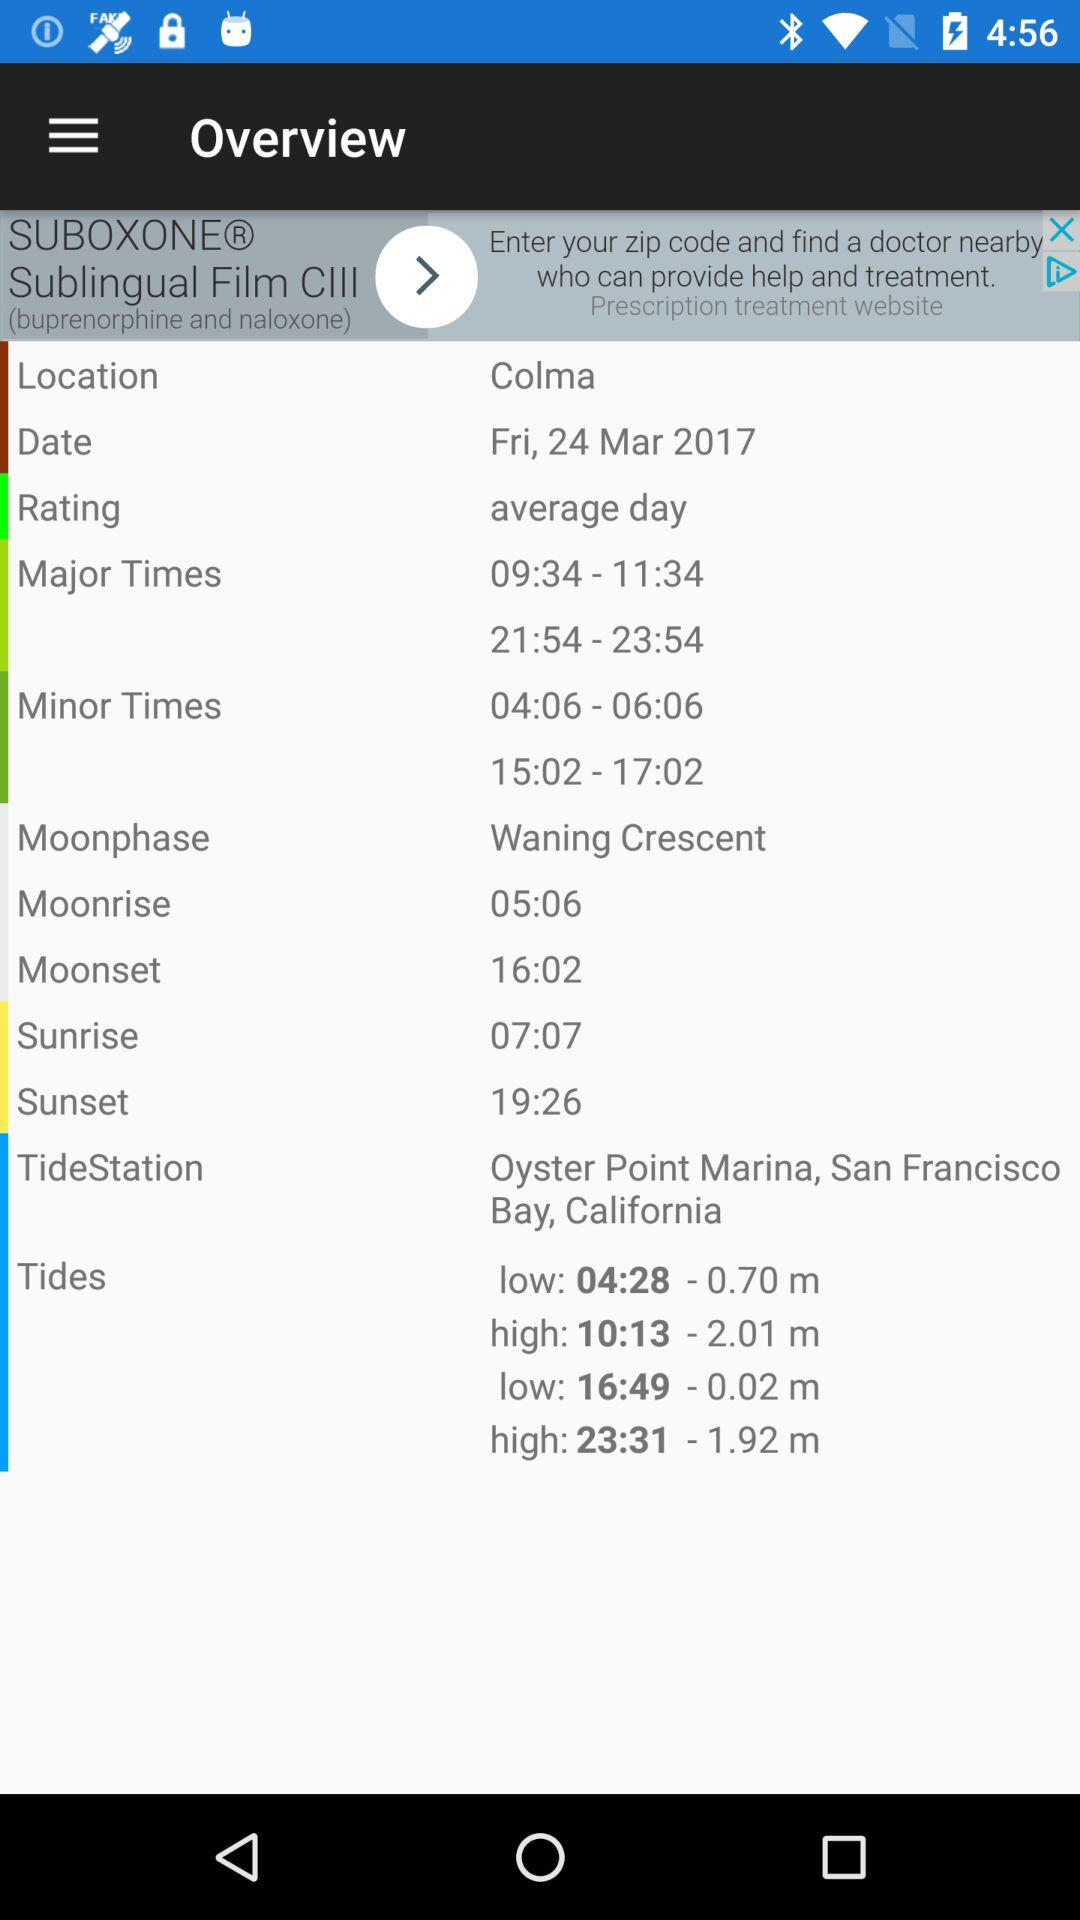What is the date? The date is Friday, March 24, 2017. 